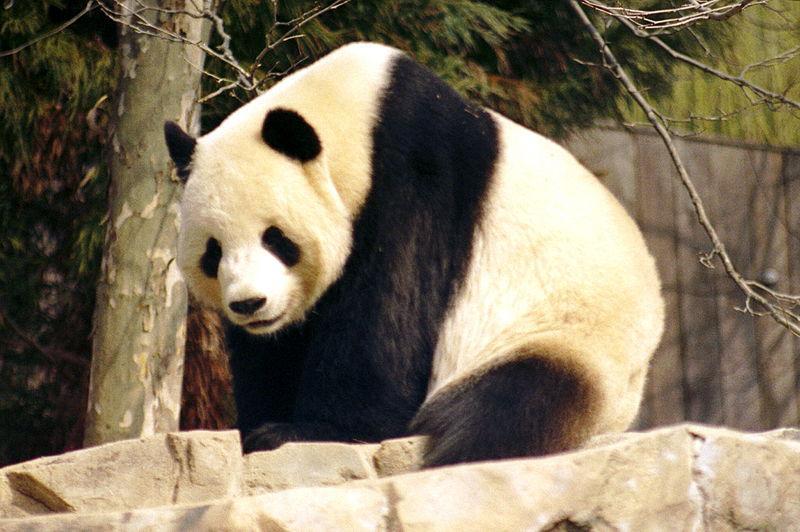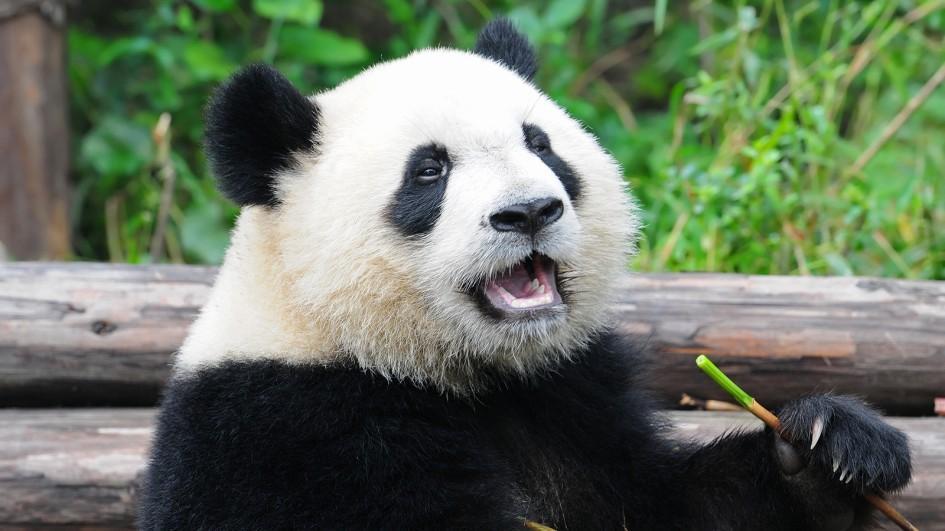The first image is the image on the left, the second image is the image on the right. Examine the images to the left and right. Is the description "There are at least two pandas in one of the images." accurate? Answer yes or no. No. 